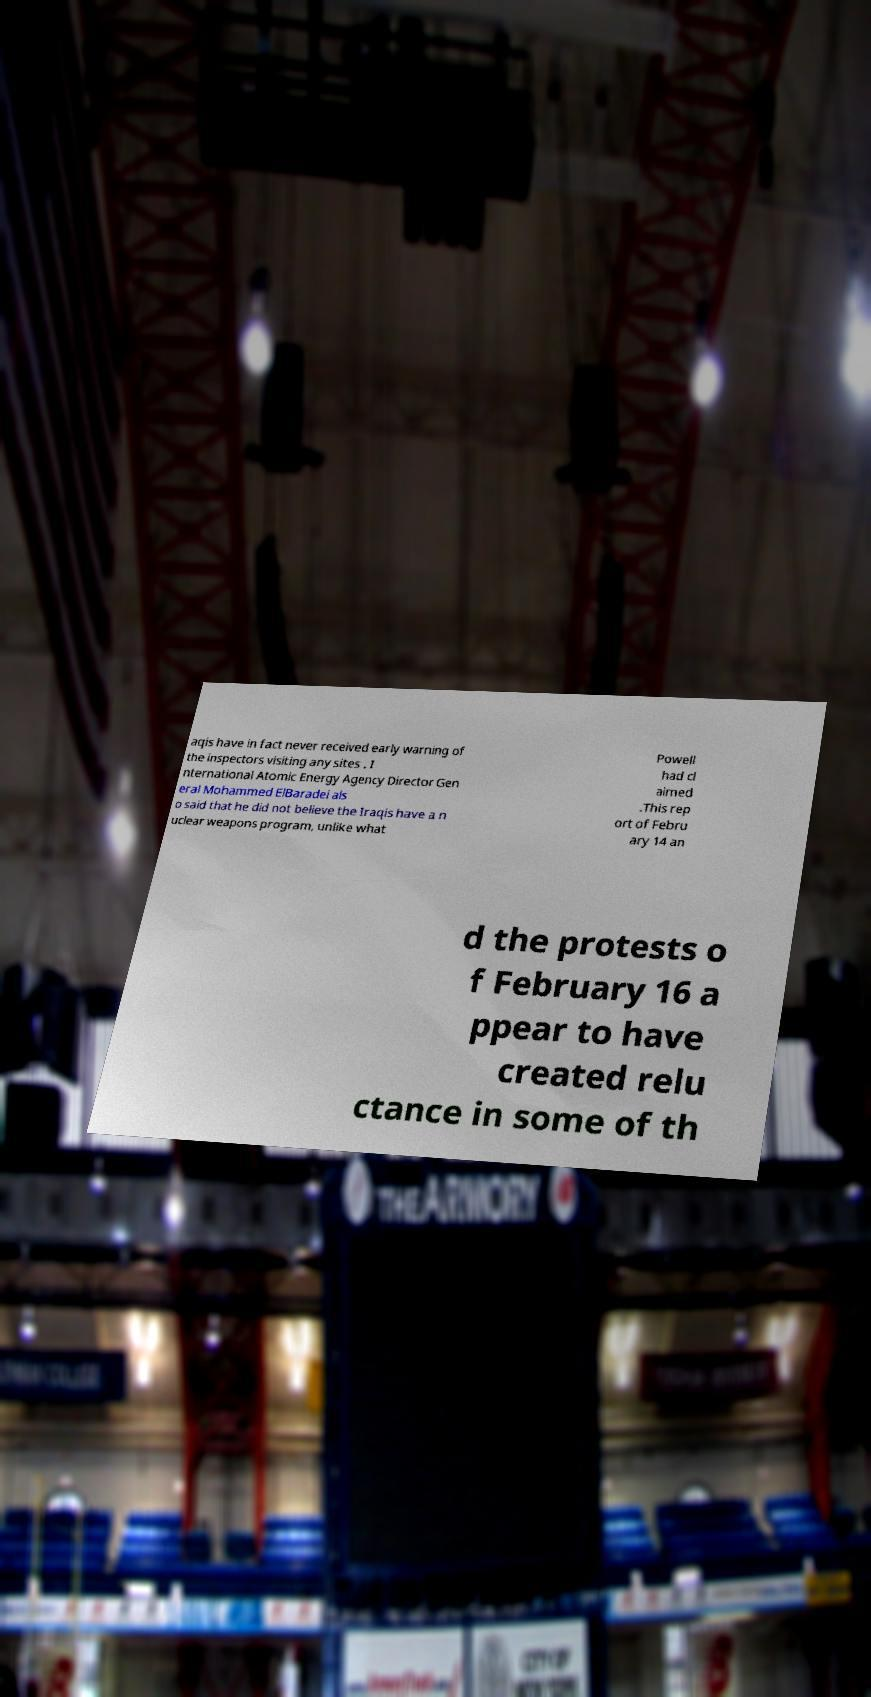Could you extract and type out the text from this image? aqis have in fact never received early warning of the inspectors visiting any sites . I nternational Atomic Energy Agency Director Gen eral Mohammed ElBaradei als o said that he did not believe the Iraqis have a n uclear weapons program, unlike what Powell had cl aimed .This rep ort of Febru ary 14 an d the protests o f February 16 a ppear to have created relu ctance in some of th 